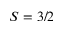Convert formula to latex. <formula><loc_0><loc_0><loc_500><loc_500>S = 3 / 2</formula> 